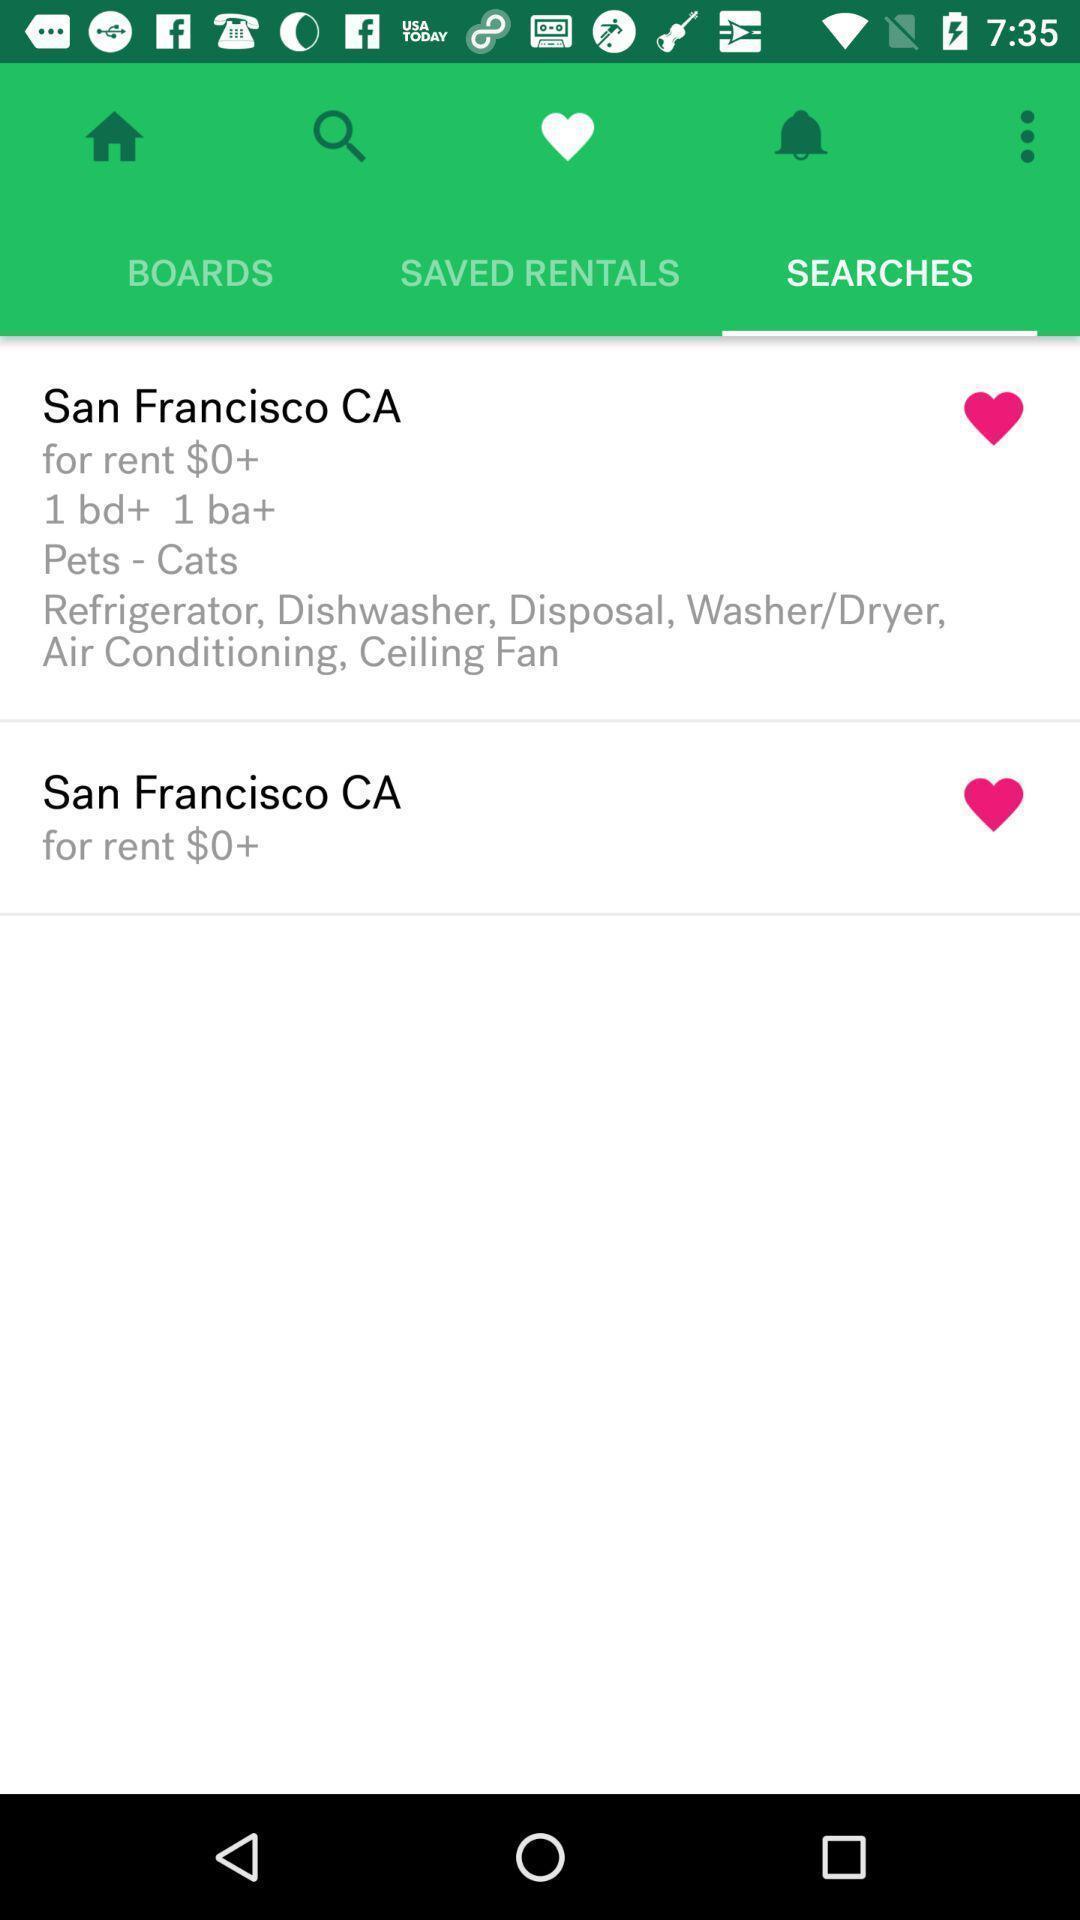Provide a description of this screenshot. Two records are there under search option. 